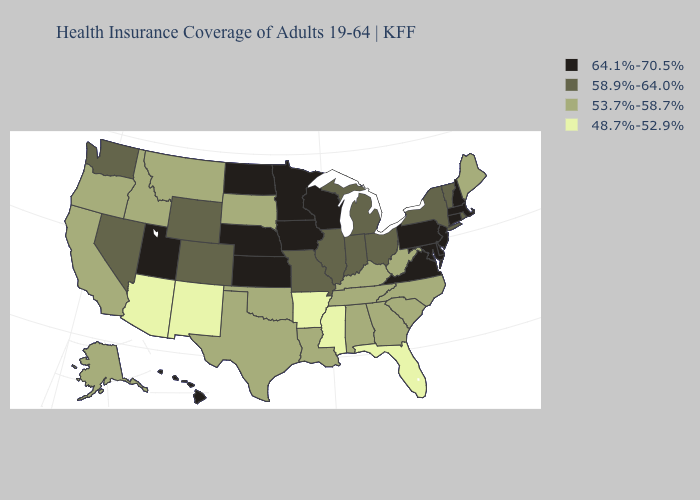Among the states that border West Virginia , which have the lowest value?
Write a very short answer. Kentucky. Which states have the highest value in the USA?
Write a very short answer. Connecticut, Delaware, Hawaii, Iowa, Kansas, Maryland, Massachusetts, Minnesota, Nebraska, New Hampshire, New Jersey, North Dakota, Pennsylvania, Utah, Virginia, Wisconsin. Does New Hampshire have the highest value in the USA?
Keep it brief. Yes. Name the states that have a value in the range 53.7%-58.7%?
Write a very short answer. Alabama, Alaska, California, Georgia, Idaho, Kentucky, Louisiana, Maine, Montana, North Carolina, Oklahoma, Oregon, South Carolina, South Dakota, Tennessee, Texas, West Virginia. Does Maine have the highest value in the Northeast?
Short answer required. No. What is the lowest value in states that border Georgia?
Concise answer only. 48.7%-52.9%. Which states hav the highest value in the MidWest?
Short answer required. Iowa, Kansas, Minnesota, Nebraska, North Dakota, Wisconsin. What is the value of Minnesota?
Give a very brief answer. 64.1%-70.5%. Name the states that have a value in the range 53.7%-58.7%?
Short answer required. Alabama, Alaska, California, Georgia, Idaho, Kentucky, Louisiana, Maine, Montana, North Carolina, Oklahoma, Oregon, South Carolina, South Dakota, Tennessee, Texas, West Virginia. What is the highest value in the USA?
Write a very short answer. 64.1%-70.5%. Name the states that have a value in the range 53.7%-58.7%?
Quick response, please. Alabama, Alaska, California, Georgia, Idaho, Kentucky, Louisiana, Maine, Montana, North Carolina, Oklahoma, Oregon, South Carolina, South Dakota, Tennessee, Texas, West Virginia. Name the states that have a value in the range 53.7%-58.7%?
Answer briefly. Alabama, Alaska, California, Georgia, Idaho, Kentucky, Louisiana, Maine, Montana, North Carolina, Oklahoma, Oregon, South Carolina, South Dakota, Tennessee, Texas, West Virginia. Name the states that have a value in the range 48.7%-52.9%?
Give a very brief answer. Arizona, Arkansas, Florida, Mississippi, New Mexico. Among the states that border Michigan , which have the highest value?
Keep it brief. Wisconsin. Which states have the highest value in the USA?
Answer briefly. Connecticut, Delaware, Hawaii, Iowa, Kansas, Maryland, Massachusetts, Minnesota, Nebraska, New Hampshire, New Jersey, North Dakota, Pennsylvania, Utah, Virginia, Wisconsin. 